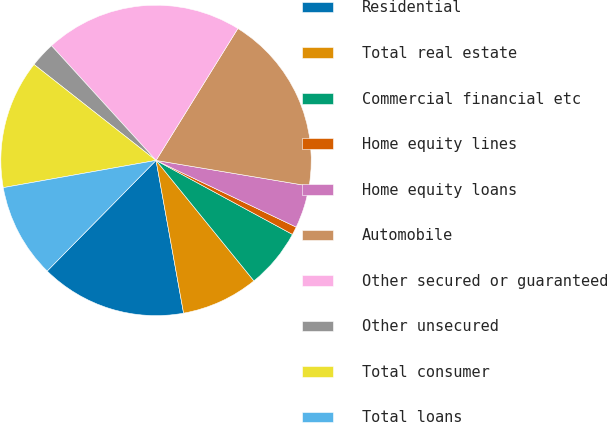Convert chart. <chart><loc_0><loc_0><loc_500><loc_500><pie_chart><fcel>Residential<fcel>Total real estate<fcel>Commercial financial etc<fcel>Home equity lines<fcel>Home equity loans<fcel>Automobile<fcel>Other secured or guaranteed<fcel>Other unsecured<fcel>Total consumer<fcel>Total loans<nl><fcel>15.21%<fcel>8.02%<fcel>6.23%<fcel>0.84%<fcel>4.43%<fcel>18.8%<fcel>20.6%<fcel>2.63%<fcel>13.41%<fcel>9.82%<nl></chart> 